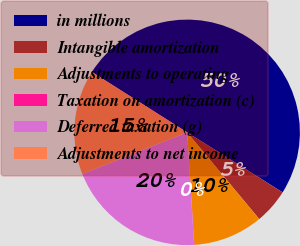Convert chart. <chart><loc_0><loc_0><loc_500><loc_500><pie_chart><fcel>in millions<fcel>Intangible amortization<fcel>Adjustments to operating<fcel>Taxation on amortization (c)<fcel>Deferred taxation (g)<fcel>Adjustments to net income<nl><fcel>49.93%<fcel>5.03%<fcel>10.01%<fcel>0.04%<fcel>19.99%<fcel>15.0%<nl></chart> 